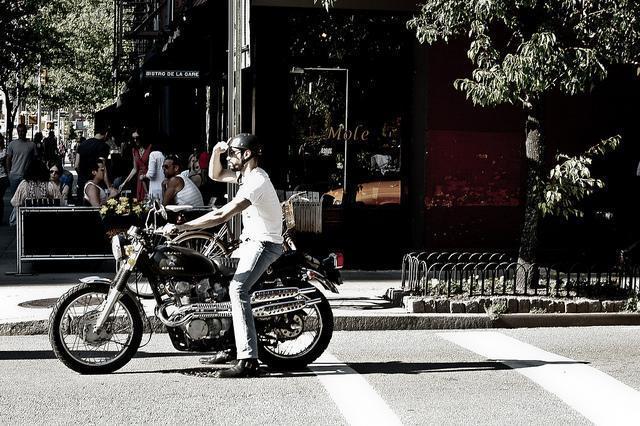How many people are on the motorcycle?
Give a very brief answer. 1. 